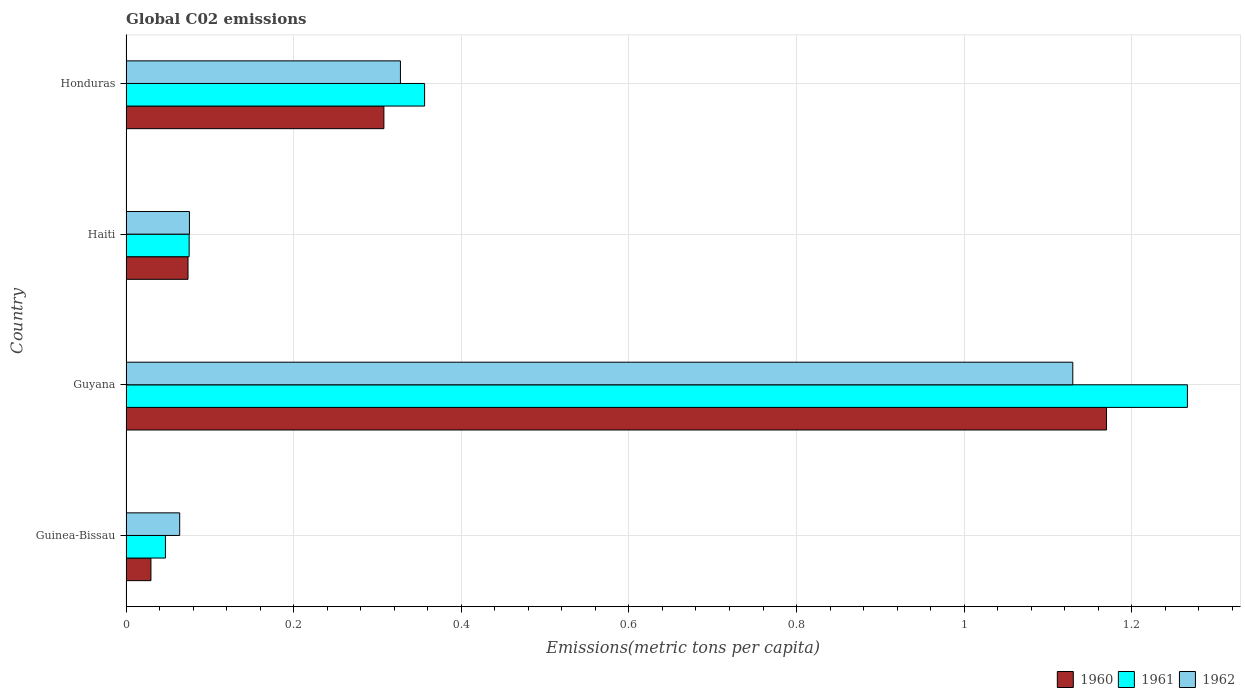How many groups of bars are there?
Offer a very short reply. 4. How many bars are there on the 3rd tick from the bottom?
Ensure brevity in your answer.  3. What is the label of the 4th group of bars from the top?
Offer a terse response. Guinea-Bissau. What is the amount of CO2 emitted in in 1961 in Honduras?
Offer a terse response. 0.36. Across all countries, what is the maximum amount of CO2 emitted in in 1960?
Your answer should be very brief. 1.17. Across all countries, what is the minimum amount of CO2 emitted in in 1962?
Give a very brief answer. 0.06. In which country was the amount of CO2 emitted in in 1960 maximum?
Keep it short and to the point. Guyana. In which country was the amount of CO2 emitted in in 1960 minimum?
Your response must be concise. Guinea-Bissau. What is the total amount of CO2 emitted in in 1961 in the graph?
Keep it short and to the point. 1.74. What is the difference between the amount of CO2 emitted in in 1961 in Guinea-Bissau and that in Guyana?
Ensure brevity in your answer.  -1.22. What is the difference between the amount of CO2 emitted in in 1962 in Guyana and the amount of CO2 emitted in in 1960 in Haiti?
Give a very brief answer. 1.06. What is the average amount of CO2 emitted in in 1961 per country?
Offer a terse response. 0.44. What is the difference between the amount of CO2 emitted in in 1962 and amount of CO2 emitted in in 1961 in Honduras?
Ensure brevity in your answer.  -0.03. In how many countries, is the amount of CO2 emitted in in 1961 greater than 0.24000000000000002 metric tons per capita?
Make the answer very short. 2. What is the ratio of the amount of CO2 emitted in in 1961 in Guinea-Bissau to that in Honduras?
Ensure brevity in your answer.  0.13. What is the difference between the highest and the second highest amount of CO2 emitted in in 1961?
Provide a short and direct response. 0.91. What is the difference between the highest and the lowest amount of CO2 emitted in in 1961?
Your answer should be compact. 1.22. In how many countries, is the amount of CO2 emitted in in 1961 greater than the average amount of CO2 emitted in in 1961 taken over all countries?
Make the answer very short. 1. What does the 1st bar from the top in Haiti represents?
Offer a terse response. 1962. What does the 2nd bar from the bottom in Haiti represents?
Make the answer very short. 1961. Are the values on the major ticks of X-axis written in scientific E-notation?
Make the answer very short. No. Does the graph contain any zero values?
Ensure brevity in your answer.  No. Does the graph contain grids?
Ensure brevity in your answer.  Yes. Where does the legend appear in the graph?
Ensure brevity in your answer.  Bottom right. How many legend labels are there?
Provide a succinct answer. 3. What is the title of the graph?
Offer a terse response. Global C02 emissions. What is the label or title of the X-axis?
Give a very brief answer. Emissions(metric tons per capita). What is the label or title of the Y-axis?
Your answer should be compact. Country. What is the Emissions(metric tons per capita) in 1960 in Guinea-Bissau?
Give a very brief answer. 0.03. What is the Emissions(metric tons per capita) of 1961 in Guinea-Bissau?
Offer a terse response. 0.05. What is the Emissions(metric tons per capita) in 1962 in Guinea-Bissau?
Ensure brevity in your answer.  0.06. What is the Emissions(metric tons per capita) of 1960 in Guyana?
Provide a succinct answer. 1.17. What is the Emissions(metric tons per capita) of 1961 in Guyana?
Offer a terse response. 1.27. What is the Emissions(metric tons per capita) in 1962 in Guyana?
Ensure brevity in your answer.  1.13. What is the Emissions(metric tons per capita) in 1960 in Haiti?
Offer a very short reply. 0.07. What is the Emissions(metric tons per capita) in 1961 in Haiti?
Your answer should be compact. 0.08. What is the Emissions(metric tons per capita) of 1962 in Haiti?
Offer a terse response. 0.08. What is the Emissions(metric tons per capita) in 1960 in Honduras?
Provide a succinct answer. 0.31. What is the Emissions(metric tons per capita) in 1961 in Honduras?
Keep it short and to the point. 0.36. What is the Emissions(metric tons per capita) in 1962 in Honduras?
Your answer should be very brief. 0.33. Across all countries, what is the maximum Emissions(metric tons per capita) in 1960?
Keep it short and to the point. 1.17. Across all countries, what is the maximum Emissions(metric tons per capita) in 1961?
Provide a short and direct response. 1.27. Across all countries, what is the maximum Emissions(metric tons per capita) in 1962?
Your answer should be very brief. 1.13. Across all countries, what is the minimum Emissions(metric tons per capita) of 1960?
Keep it short and to the point. 0.03. Across all countries, what is the minimum Emissions(metric tons per capita) of 1961?
Give a very brief answer. 0.05. Across all countries, what is the minimum Emissions(metric tons per capita) of 1962?
Offer a very short reply. 0.06. What is the total Emissions(metric tons per capita) in 1960 in the graph?
Make the answer very short. 1.58. What is the total Emissions(metric tons per capita) of 1961 in the graph?
Offer a very short reply. 1.75. What is the total Emissions(metric tons per capita) in 1962 in the graph?
Your answer should be very brief. 1.6. What is the difference between the Emissions(metric tons per capita) in 1960 in Guinea-Bissau and that in Guyana?
Provide a succinct answer. -1.14. What is the difference between the Emissions(metric tons per capita) of 1961 in Guinea-Bissau and that in Guyana?
Ensure brevity in your answer.  -1.22. What is the difference between the Emissions(metric tons per capita) in 1962 in Guinea-Bissau and that in Guyana?
Keep it short and to the point. -1.07. What is the difference between the Emissions(metric tons per capita) in 1960 in Guinea-Bissau and that in Haiti?
Make the answer very short. -0.04. What is the difference between the Emissions(metric tons per capita) of 1961 in Guinea-Bissau and that in Haiti?
Make the answer very short. -0.03. What is the difference between the Emissions(metric tons per capita) in 1962 in Guinea-Bissau and that in Haiti?
Provide a succinct answer. -0.01. What is the difference between the Emissions(metric tons per capita) in 1960 in Guinea-Bissau and that in Honduras?
Keep it short and to the point. -0.28. What is the difference between the Emissions(metric tons per capita) in 1961 in Guinea-Bissau and that in Honduras?
Offer a terse response. -0.31. What is the difference between the Emissions(metric tons per capita) in 1962 in Guinea-Bissau and that in Honduras?
Offer a very short reply. -0.26. What is the difference between the Emissions(metric tons per capita) in 1960 in Guyana and that in Haiti?
Offer a very short reply. 1.1. What is the difference between the Emissions(metric tons per capita) of 1961 in Guyana and that in Haiti?
Ensure brevity in your answer.  1.19. What is the difference between the Emissions(metric tons per capita) of 1962 in Guyana and that in Haiti?
Ensure brevity in your answer.  1.05. What is the difference between the Emissions(metric tons per capita) in 1960 in Guyana and that in Honduras?
Your response must be concise. 0.86. What is the difference between the Emissions(metric tons per capita) of 1961 in Guyana and that in Honduras?
Ensure brevity in your answer.  0.91. What is the difference between the Emissions(metric tons per capita) in 1962 in Guyana and that in Honduras?
Give a very brief answer. 0.8. What is the difference between the Emissions(metric tons per capita) of 1960 in Haiti and that in Honduras?
Provide a short and direct response. -0.23. What is the difference between the Emissions(metric tons per capita) in 1961 in Haiti and that in Honduras?
Give a very brief answer. -0.28. What is the difference between the Emissions(metric tons per capita) in 1962 in Haiti and that in Honduras?
Your answer should be compact. -0.25. What is the difference between the Emissions(metric tons per capita) in 1960 in Guinea-Bissau and the Emissions(metric tons per capita) in 1961 in Guyana?
Provide a short and direct response. -1.24. What is the difference between the Emissions(metric tons per capita) of 1960 in Guinea-Bissau and the Emissions(metric tons per capita) of 1962 in Guyana?
Your answer should be compact. -1.1. What is the difference between the Emissions(metric tons per capita) in 1961 in Guinea-Bissau and the Emissions(metric tons per capita) in 1962 in Guyana?
Offer a very short reply. -1.08. What is the difference between the Emissions(metric tons per capita) in 1960 in Guinea-Bissau and the Emissions(metric tons per capita) in 1961 in Haiti?
Your response must be concise. -0.05. What is the difference between the Emissions(metric tons per capita) of 1960 in Guinea-Bissau and the Emissions(metric tons per capita) of 1962 in Haiti?
Offer a very short reply. -0.05. What is the difference between the Emissions(metric tons per capita) of 1961 in Guinea-Bissau and the Emissions(metric tons per capita) of 1962 in Haiti?
Offer a terse response. -0.03. What is the difference between the Emissions(metric tons per capita) in 1960 in Guinea-Bissau and the Emissions(metric tons per capita) in 1961 in Honduras?
Offer a very short reply. -0.33. What is the difference between the Emissions(metric tons per capita) in 1960 in Guinea-Bissau and the Emissions(metric tons per capita) in 1962 in Honduras?
Your answer should be very brief. -0.3. What is the difference between the Emissions(metric tons per capita) in 1961 in Guinea-Bissau and the Emissions(metric tons per capita) in 1962 in Honduras?
Give a very brief answer. -0.28. What is the difference between the Emissions(metric tons per capita) in 1960 in Guyana and the Emissions(metric tons per capita) in 1961 in Haiti?
Provide a succinct answer. 1.09. What is the difference between the Emissions(metric tons per capita) of 1960 in Guyana and the Emissions(metric tons per capita) of 1962 in Haiti?
Make the answer very short. 1.09. What is the difference between the Emissions(metric tons per capita) in 1961 in Guyana and the Emissions(metric tons per capita) in 1962 in Haiti?
Your response must be concise. 1.19. What is the difference between the Emissions(metric tons per capita) in 1960 in Guyana and the Emissions(metric tons per capita) in 1961 in Honduras?
Make the answer very short. 0.81. What is the difference between the Emissions(metric tons per capita) of 1960 in Guyana and the Emissions(metric tons per capita) of 1962 in Honduras?
Provide a short and direct response. 0.84. What is the difference between the Emissions(metric tons per capita) in 1961 in Guyana and the Emissions(metric tons per capita) in 1962 in Honduras?
Provide a short and direct response. 0.94. What is the difference between the Emissions(metric tons per capita) in 1960 in Haiti and the Emissions(metric tons per capita) in 1961 in Honduras?
Your response must be concise. -0.28. What is the difference between the Emissions(metric tons per capita) of 1960 in Haiti and the Emissions(metric tons per capita) of 1962 in Honduras?
Provide a short and direct response. -0.25. What is the difference between the Emissions(metric tons per capita) in 1961 in Haiti and the Emissions(metric tons per capita) in 1962 in Honduras?
Make the answer very short. -0.25. What is the average Emissions(metric tons per capita) in 1960 per country?
Offer a terse response. 0.4. What is the average Emissions(metric tons per capita) of 1961 per country?
Offer a very short reply. 0.44. What is the average Emissions(metric tons per capita) in 1962 per country?
Provide a short and direct response. 0.4. What is the difference between the Emissions(metric tons per capita) in 1960 and Emissions(metric tons per capita) in 1961 in Guinea-Bissau?
Your answer should be compact. -0.02. What is the difference between the Emissions(metric tons per capita) in 1960 and Emissions(metric tons per capita) in 1962 in Guinea-Bissau?
Give a very brief answer. -0.03. What is the difference between the Emissions(metric tons per capita) in 1961 and Emissions(metric tons per capita) in 1962 in Guinea-Bissau?
Ensure brevity in your answer.  -0.02. What is the difference between the Emissions(metric tons per capita) in 1960 and Emissions(metric tons per capita) in 1961 in Guyana?
Offer a very short reply. -0.1. What is the difference between the Emissions(metric tons per capita) of 1960 and Emissions(metric tons per capita) of 1962 in Guyana?
Give a very brief answer. 0.04. What is the difference between the Emissions(metric tons per capita) in 1961 and Emissions(metric tons per capita) in 1962 in Guyana?
Your answer should be compact. 0.14. What is the difference between the Emissions(metric tons per capita) in 1960 and Emissions(metric tons per capita) in 1961 in Haiti?
Your response must be concise. -0. What is the difference between the Emissions(metric tons per capita) of 1960 and Emissions(metric tons per capita) of 1962 in Haiti?
Ensure brevity in your answer.  -0. What is the difference between the Emissions(metric tons per capita) of 1961 and Emissions(metric tons per capita) of 1962 in Haiti?
Keep it short and to the point. -0. What is the difference between the Emissions(metric tons per capita) of 1960 and Emissions(metric tons per capita) of 1961 in Honduras?
Keep it short and to the point. -0.05. What is the difference between the Emissions(metric tons per capita) in 1960 and Emissions(metric tons per capita) in 1962 in Honduras?
Ensure brevity in your answer.  -0.02. What is the difference between the Emissions(metric tons per capita) of 1961 and Emissions(metric tons per capita) of 1962 in Honduras?
Ensure brevity in your answer.  0.03. What is the ratio of the Emissions(metric tons per capita) of 1960 in Guinea-Bissau to that in Guyana?
Your answer should be compact. 0.03. What is the ratio of the Emissions(metric tons per capita) in 1961 in Guinea-Bissau to that in Guyana?
Provide a succinct answer. 0.04. What is the ratio of the Emissions(metric tons per capita) in 1962 in Guinea-Bissau to that in Guyana?
Provide a succinct answer. 0.06. What is the ratio of the Emissions(metric tons per capita) in 1960 in Guinea-Bissau to that in Haiti?
Offer a very short reply. 0.4. What is the ratio of the Emissions(metric tons per capita) of 1961 in Guinea-Bissau to that in Haiti?
Offer a very short reply. 0.62. What is the ratio of the Emissions(metric tons per capita) of 1962 in Guinea-Bissau to that in Haiti?
Offer a terse response. 0.85. What is the ratio of the Emissions(metric tons per capita) in 1960 in Guinea-Bissau to that in Honduras?
Offer a terse response. 0.1. What is the ratio of the Emissions(metric tons per capita) of 1961 in Guinea-Bissau to that in Honduras?
Offer a very short reply. 0.13. What is the ratio of the Emissions(metric tons per capita) in 1962 in Guinea-Bissau to that in Honduras?
Make the answer very short. 0.2. What is the ratio of the Emissions(metric tons per capita) in 1960 in Guyana to that in Haiti?
Your response must be concise. 15.81. What is the ratio of the Emissions(metric tons per capita) of 1961 in Guyana to that in Haiti?
Your response must be concise. 16.81. What is the ratio of the Emissions(metric tons per capita) in 1962 in Guyana to that in Haiti?
Keep it short and to the point. 14.93. What is the ratio of the Emissions(metric tons per capita) in 1960 in Guyana to that in Honduras?
Your answer should be compact. 3.8. What is the ratio of the Emissions(metric tons per capita) in 1961 in Guyana to that in Honduras?
Provide a short and direct response. 3.55. What is the ratio of the Emissions(metric tons per capita) of 1962 in Guyana to that in Honduras?
Offer a very short reply. 3.45. What is the ratio of the Emissions(metric tons per capita) in 1960 in Haiti to that in Honduras?
Ensure brevity in your answer.  0.24. What is the ratio of the Emissions(metric tons per capita) of 1961 in Haiti to that in Honduras?
Your answer should be compact. 0.21. What is the ratio of the Emissions(metric tons per capita) of 1962 in Haiti to that in Honduras?
Offer a terse response. 0.23. What is the difference between the highest and the second highest Emissions(metric tons per capita) of 1960?
Your answer should be very brief. 0.86. What is the difference between the highest and the second highest Emissions(metric tons per capita) of 1961?
Make the answer very short. 0.91. What is the difference between the highest and the second highest Emissions(metric tons per capita) of 1962?
Give a very brief answer. 0.8. What is the difference between the highest and the lowest Emissions(metric tons per capita) of 1960?
Keep it short and to the point. 1.14. What is the difference between the highest and the lowest Emissions(metric tons per capita) of 1961?
Your answer should be very brief. 1.22. What is the difference between the highest and the lowest Emissions(metric tons per capita) of 1962?
Your answer should be compact. 1.07. 